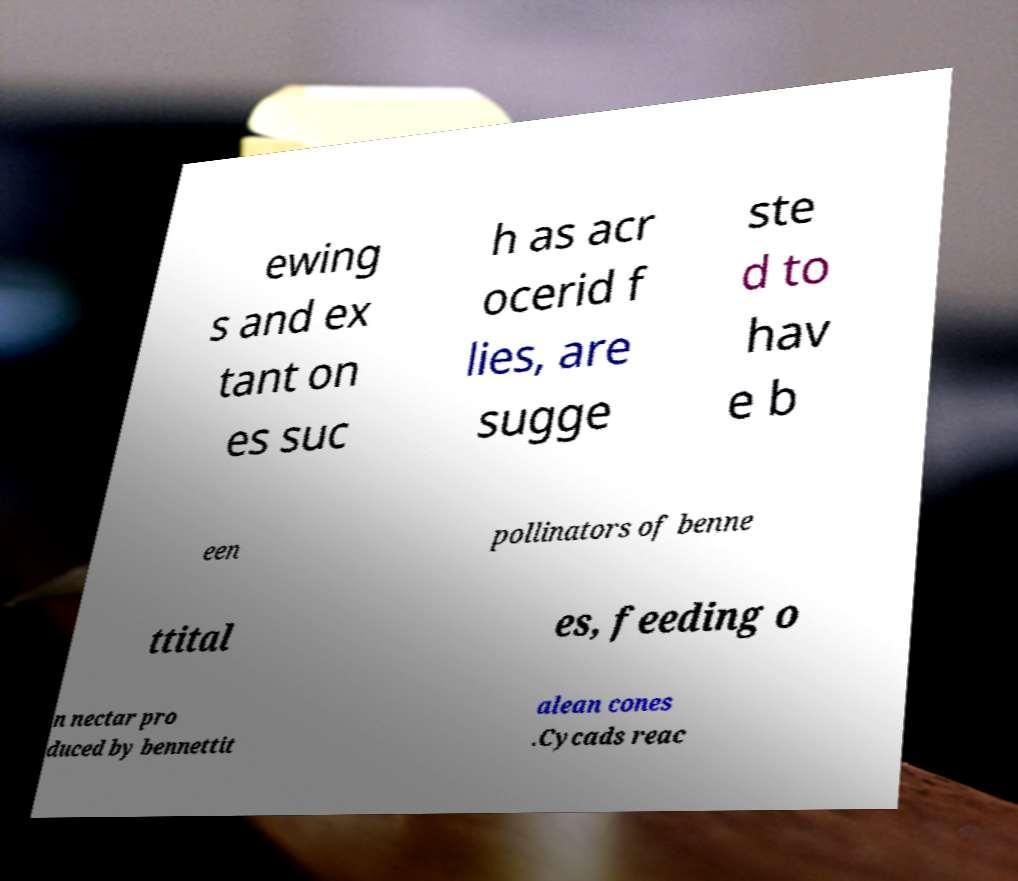Please identify and transcribe the text found in this image. ewing s and ex tant on es suc h as acr ocerid f lies, are sugge ste d to hav e b een pollinators of benne ttital es, feeding o n nectar pro duced by bennettit alean cones .Cycads reac 